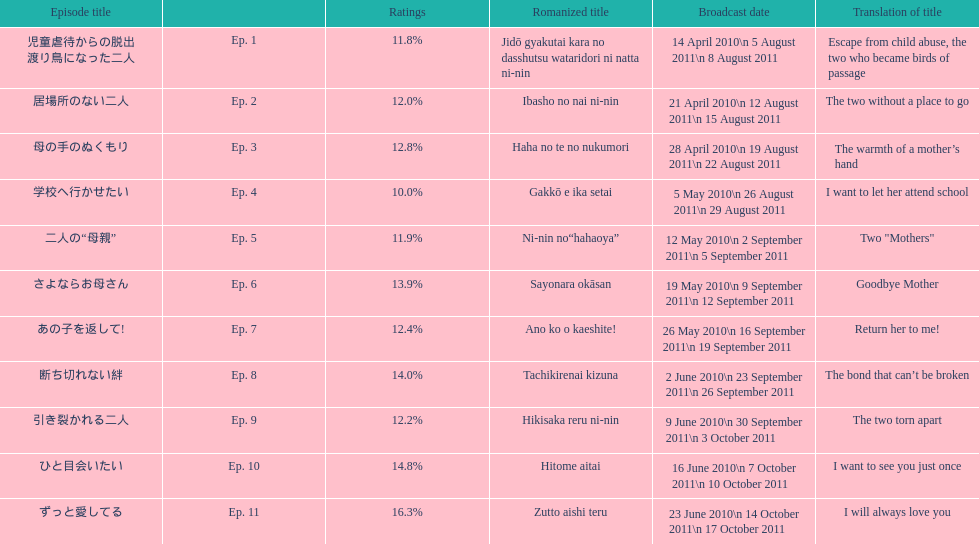What are the rating percentages for each episode? 11.8%, 12.0%, 12.8%, 10.0%, 11.9%, 13.9%, 12.4%, 14.0%, 12.2%, 14.8%, 16.3%. What is the highest rating an episode got? 16.3%. What episode got a rating of 16.3%? ずっと愛してる. 